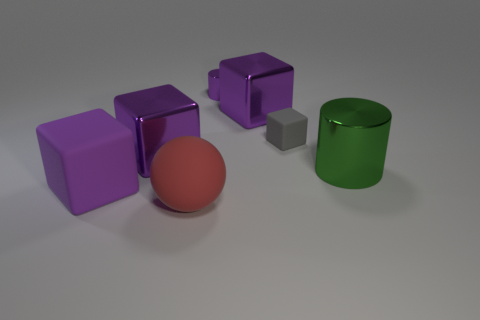Subtract all red cylinders. How many purple blocks are left? 3 Add 2 cyan rubber objects. How many objects exist? 9 Subtract all balls. How many objects are left? 6 Add 1 tiny purple cylinders. How many tiny purple cylinders are left? 2 Add 6 shiny objects. How many shiny objects exist? 10 Subtract 0 yellow cylinders. How many objects are left? 7 Subtract all small red objects. Subtract all rubber spheres. How many objects are left? 6 